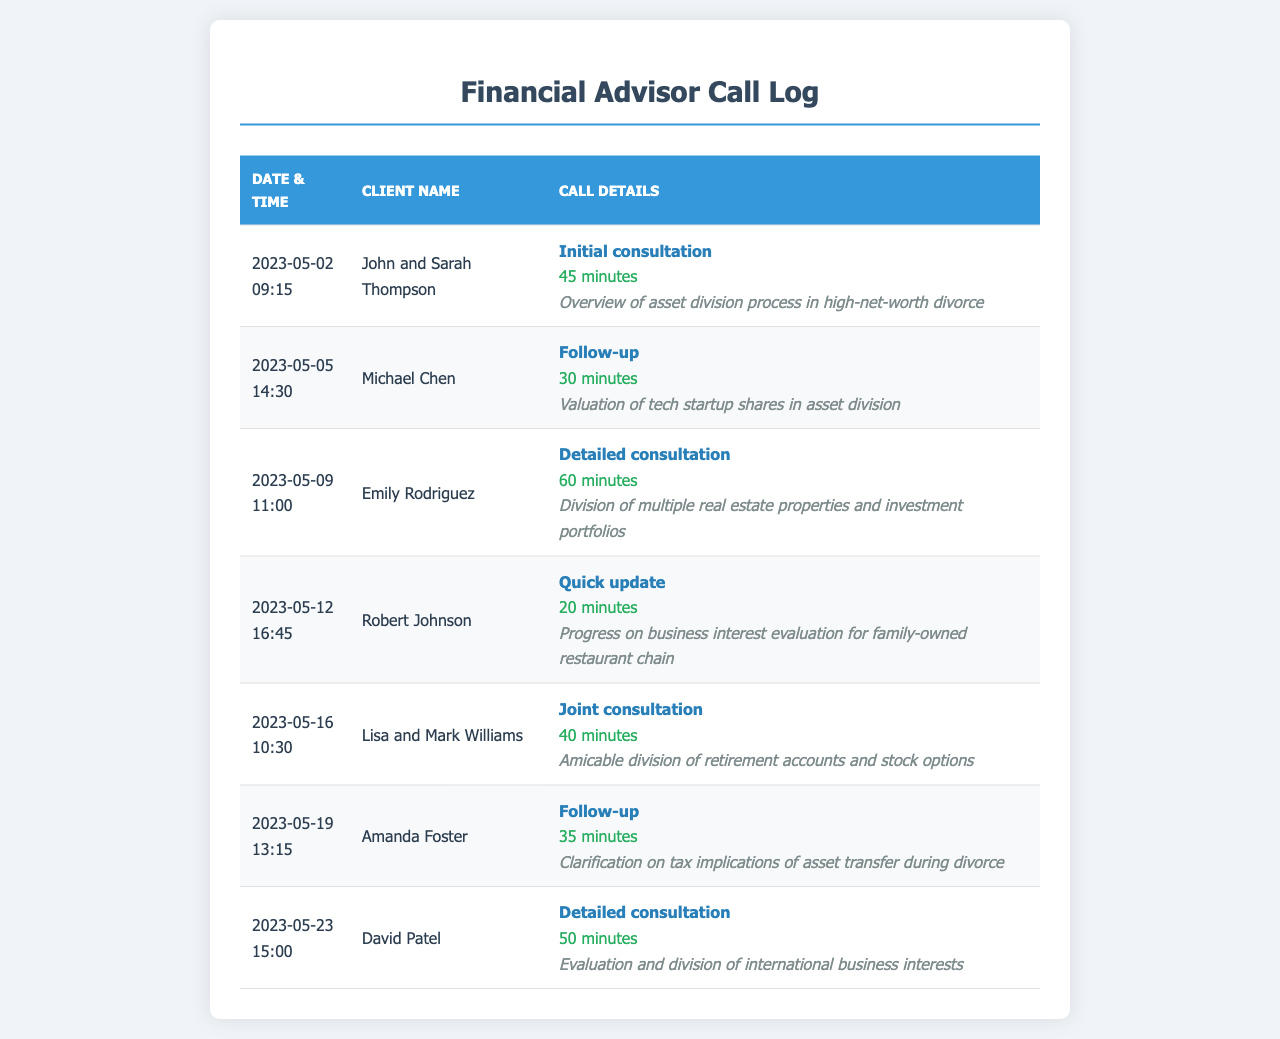What is the duration of the call with John and Sarah Thompson? The duration is specified in the details of the call log for John and Sarah Thompson.
Answer: 45 minutes What was the topic of the call on May 9th? The topic can be found under the call details for the consultation on May 9th.
Answer: Division of multiple real estate properties and investment portfolios Who had a follow-up call regarding tax implications? The client's name is indicated in the call details for that particular date.
Answer: Amanda Foster How many clients had joint consultations? The number of joint consultations can be determined by reviewing the entries in the call log.
Answer: 1 What is the total call duration for the detailed consultations? The total duration is the sum of the call durations for detailed consultations: 60 minutes + 50 minutes.
Answer: 110 minutes When did the quick update call occur? The date is provided in the call log for the quick update call.
Answer: 2023-05-12 What is the call type for the consultation with David Patel? The call type is mentioned in the call details for David Patel's consultation.
Answer: Detailed consultation How many follow-up calls are recorded in the document? The total number of follow-up calls can be counted from the entries in the call log.
Answer: 2 What was the subject of discussion in the call with Lisa and Mark Williams? The subject or topic of discussion for that particular call is listed in the call details.
Answer: Amicable division of retirement accounts and stock options 